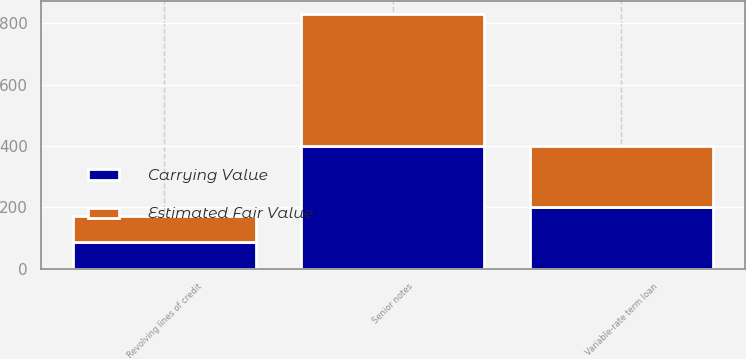Convert chart to OTSL. <chart><loc_0><loc_0><loc_500><loc_500><stacked_bar_chart><ecel><fcel>Revolving lines of credit<fcel>Variable-rate term loan<fcel>Senior notes<nl><fcel>Carrying Value<fcel>85.8<fcel>200<fcel>399.5<nl><fcel>Estimated Fair Value<fcel>85.8<fcel>200<fcel>429.9<nl></chart> 